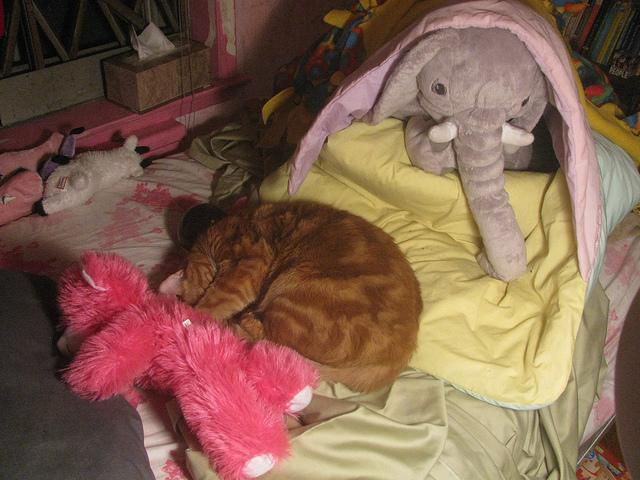Is there a real cat on the bed?
Write a very short answer. Yes. What is in the sleeping bag?
Keep it brief. Elephant. What is in the box by the window?
Be succinct. Tissues. 